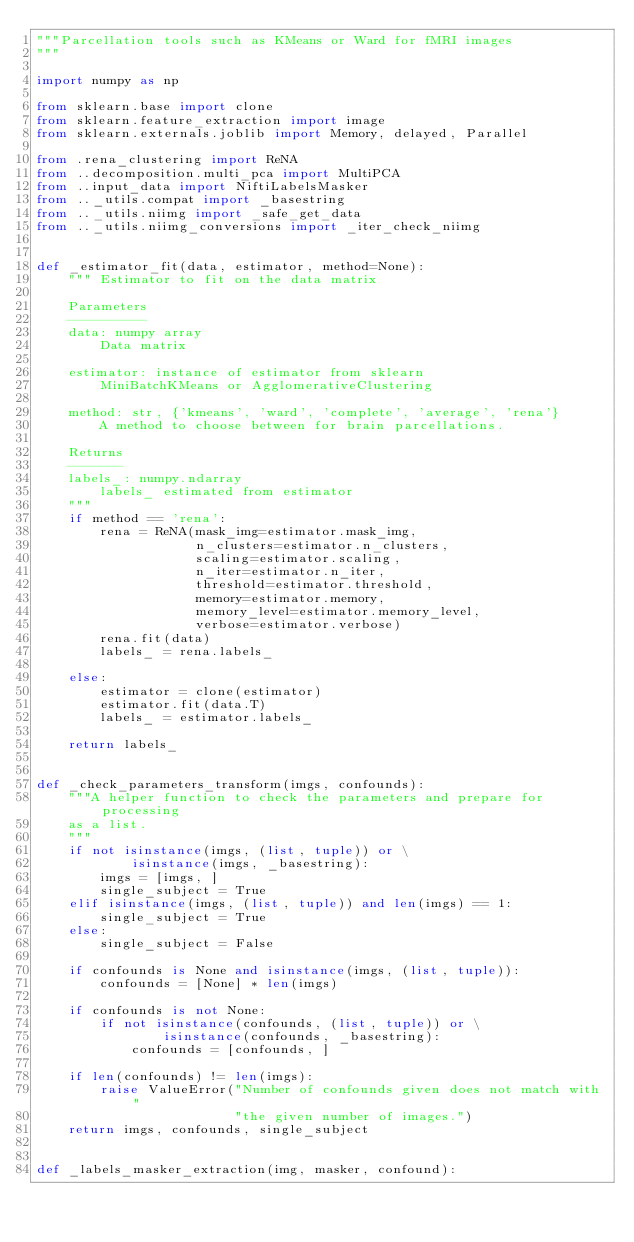<code> <loc_0><loc_0><loc_500><loc_500><_Python_>"""Parcellation tools such as KMeans or Ward for fMRI images
"""

import numpy as np

from sklearn.base import clone
from sklearn.feature_extraction import image
from sklearn.externals.joblib import Memory, delayed, Parallel

from .rena_clustering import ReNA
from ..decomposition.multi_pca import MultiPCA
from ..input_data import NiftiLabelsMasker
from .._utils.compat import _basestring
from .._utils.niimg import _safe_get_data
from .._utils.niimg_conversions import _iter_check_niimg


def _estimator_fit(data, estimator, method=None):
    """ Estimator to fit on the data matrix

    Parameters
    ----------
    data: numpy array
        Data matrix

    estimator: instance of estimator from sklearn
        MiniBatchKMeans or AgglomerativeClustering

    method: str, {'kmeans', 'ward', 'complete', 'average', 'rena'}
        A method to choose between for brain parcellations.

    Returns
    -------
    labels_: numpy.ndarray
        labels_ estimated from estimator
    """
    if method == 'rena':
        rena = ReNA(mask_img=estimator.mask_img,
                    n_clusters=estimator.n_clusters,
                    scaling=estimator.scaling,
                    n_iter=estimator.n_iter,
                    threshold=estimator.threshold,
                    memory=estimator.memory,
                    memory_level=estimator.memory_level,
                    verbose=estimator.verbose)
        rena.fit(data)
        labels_ = rena.labels_

    else:
        estimator = clone(estimator)
        estimator.fit(data.T)
        labels_ = estimator.labels_

    return labels_


def _check_parameters_transform(imgs, confounds):
    """A helper function to check the parameters and prepare for processing
    as a list.
    """
    if not isinstance(imgs, (list, tuple)) or \
            isinstance(imgs, _basestring):
        imgs = [imgs, ]
        single_subject = True
    elif isinstance(imgs, (list, tuple)) and len(imgs) == 1:
        single_subject = True
    else:
        single_subject = False

    if confounds is None and isinstance(imgs, (list, tuple)):
        confounds = [None] * len(imgs)

    if confounds is not None:
        if not isinstance(confounds, (list, tuple)) or \
                isinstance(confounds, _basestring):
            confounds = [confounds, ]

    if len(confounds) != len(imgs):
        raise ValueError("Number of confounds given does not match with "
                         "the given number of images.")
    return imgs, confounds, single_subject


def _labels_masker_extraction(img, masker, confound):</code> 